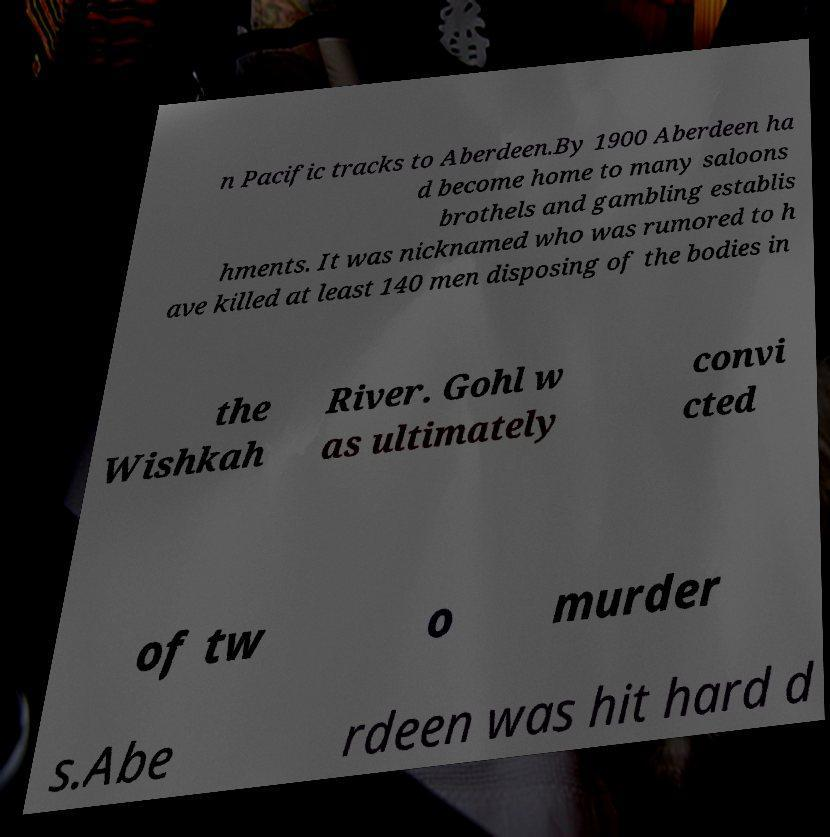For documentation purposes, I need the text within this image transcribed. Could you provide that? n Pacific tracks to Aberdeen.By 1900 Aberdeen ha d become home to many saloons brothels and gambling establis hments. It was nicknamed who was rumored to h ave killed at least 140 men disposing of the bodies in the Wishkah River. Gohl w as ultimately convi cted of tw o murder s.Abe rdeen was hit hard d 